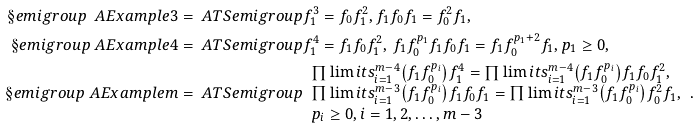<formula> <loc_0><loc_0><loc_500><loc_500>\S e m i g r o u p { \ A E x a m p l e { 3 } } & = \ A T S e m i g r o u p { f _ { 1 } ^ { 3 } = f _ { 0 } f _ { 1 } ^ { 2 } , f _ { 1 } f _ { 0 } f _ { 1 } = f _ { 0 } ^ { 2 } f _ { 1 } } , \\ \S e m i g r o u p { \ A E x a m p l e { 4 } } & = \ A T S e m i g r o u p { f _ { 1 } ^ { 4 } = f _ { 1 } f _ { 0 } f _ { 1 } ^ { 2 } , \, f _ { 1 } f _ { 0 } ^ { p _ { 1 } } f _ { 1 } f _ { 0 } f _ { 1 } = f _ { 1 } f _ { 0 } ^ { p _ { 1 } + 2 } f _ { 1 } , p _ { 1 } \geq 0 } , \\ \S e m i g r o u p { \ A E x a m p l e { m } } & = \ A T S e m i g r o u p { { \begin{array} { l } { \prod \lim i t s _ { i = 1 } ^ { m - 4 } { \left ( { f _ { 1 } f _ { 0 } ^ { p _ { i } } } \right ) } f _ { 1 } ^ { 4 } = \prod \lim i t s _ { i = 1 } ^ { m - 4 } { \left ( { f _ { 1 } f _ { 0 } ^ { p _ { i } } } \right ) } f _ { 1 } f _ { 0 } f _ { 1 } ^ { 2 } , } \\ { \prod \lim i t s _ { i = 1 } ^ { m - 3 } { \left ( { f _ { 1 } f _ { 0 } ^ { p _ { i } } } \right ) } f _ { 1 } f _ { 0 } f _ { 1 } = \prod \lim i t s _ { i = 1 } ^ { m - 3 } { \left ( { f _ { 1 } f _ { 0 } ^ { p _ { i } } } \right ) } f _ { 0 } ^ { 2 } f _ { 1 } , } \\ { p _ { i } \geq 0 , i = 1 , 2 , \dots , { m - 3 } } \end{array} } } .</formula> 